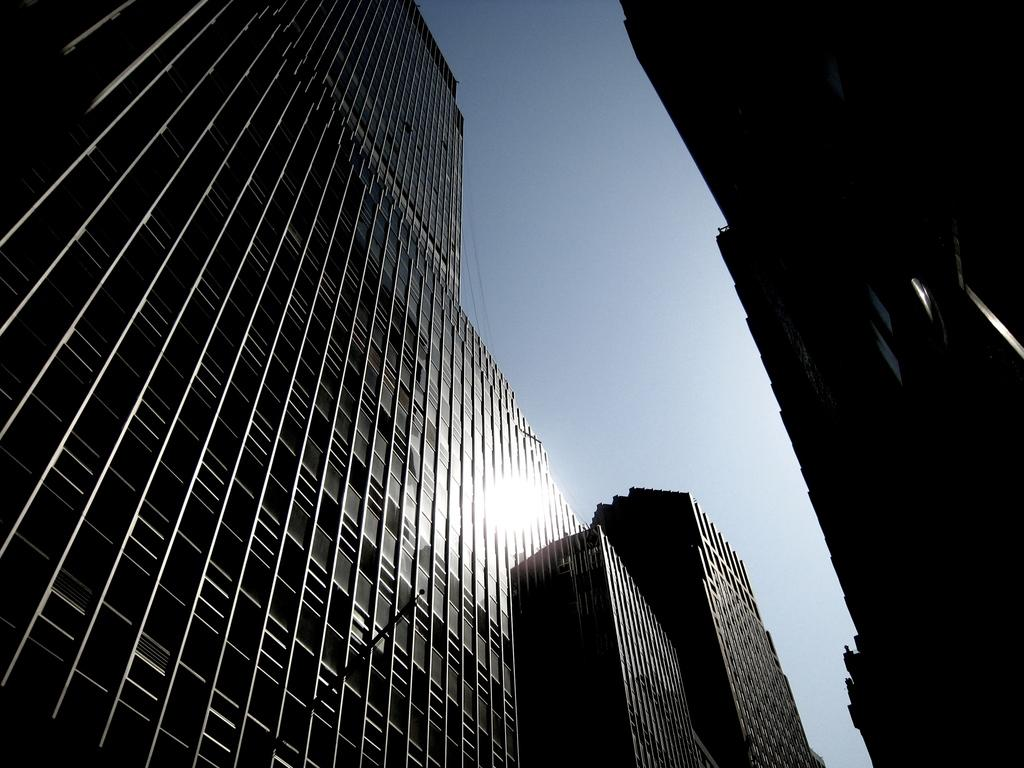What type of structures can be seen in the image? There are buildings in the image. What part of the natural environment is visible in the image? The sky is visible in the image. Can you determine the time of day based on the image? The image was likely taken during the day, as the sky appears bright. What type of pet can be seen in the image? There is no pet visible in the image. What type of can is present in the image? There is no can present in the image. 